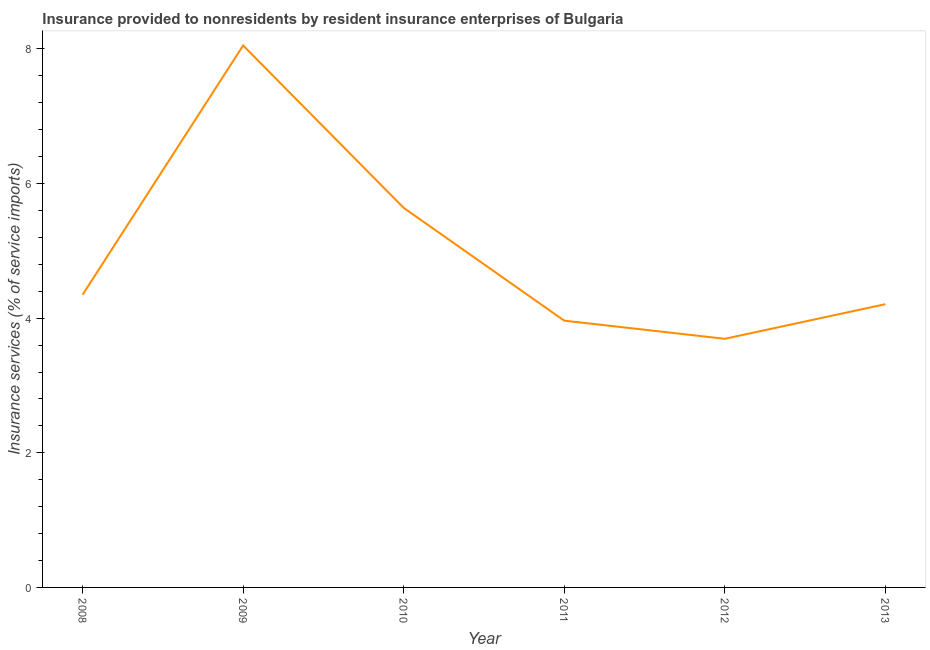What is the insurance and financial services in 2012?
Your answer should be compact. 3.69. Across all years, what is the maximum insurance and financial services?
Your answer should be very brief. 8.05. Across all years, what is the minimum insurance and financial services?
Make the answer very short. 3.69. What is the sum of the insurance and financial services?
Your answer should be very brief. 29.9. What is the difference between the insurance and financial services in 2012 and 2013?
Give a very brief answer. -0.51. What is the average insurance and financial services per year?
Make the answer very short. 4.98. What is the median insurance and financial services?
Make the answer very short. 4.28. What is the ratio of the insurance and financial services in 2008 to that in 2009?
Your response must be concise. 0.54. Is the insurance and financial services in 2010 less than that in 2013?
Make the answer very short. No. What is the difference between the highest and the second highest insurance and financial services?
Ensure brevity in your answer.  2.41. What is the difference between the highest and the lowest insurance and financial services?
Provide a succinct answer. 4.36. How many lines are there?
Make the answer very short. 1. Does the graph contain any zero values?
Offer a terse response. No. Does the graph contain grids?
Make the answer very short. No. What is the title of the graph?
Your answer should be compact. Insurance provided to nonresidents by resident insurance enterprises of Bulgaria. What is the label or title of the X-axis?
Offer a terse response. Year. What is the label or title of the Y-axis?
Your answer should be very brief. Insurance services (% of service imports). What is the Insurance services (% of service imports) of 2008?
Offer a terse response. 4.35. What is the Insurance services (% of service imports) of 2009?
Offer a very short reply. 8.05. What is the Insurance services (% of service imports) in 2010?
Your answer should be compact. 5.64. What is the Insurance services (% of service imports) of 2011?
Make the answer very short. 3.96. What is the Insurance services (% of service imports) of 2012?
Offer a terse response. 3.69. What is the Insurance services (% of service imports) of 2013?
Provide a short and direct response. 4.21. What is the difference between the Insurance services (% of service imports) in 2008 and 2009?
Provide a succinct answer. -3.7. What is the difference between the Insurance services (% of service imports) in 2008 and 2010?
Provide a short and direct response. -1.29. What is the difference between the Insurance services (% of service imports) in 2008 and 2011?
Keep it short and to the point. 0.38. What is the difference between the Insurance services (% of service imports) in 2008 and 2012?
Provide a short and direct response. 0.65. What is the difference between the Insurance services (% of service imports) in 2008 and 2013?
Offer a very short reply. 0.14. What is the difference between the Insurance services (% of service imports) in 2009 and 2010?
Provide a short and direct response. 2.41. What is the difference between the Insurance services (% of service imports) in 2009 and 2011?
Give a very brief answer. 4.09. What is the difference between the Insurance services (% of service imports) in 2009 and 2012?
Offer a terse response. 4.36. What is the difference between the Insurance services (% of service imports) in 2009 and 2013?
Your answer should be very brief. 3.84. What is the difference between the Insurance services (% of service imports) in 2010 and 2011?
Ensure brevity in your answer.  1.68. What is the difference between the Insurance services (% of service imports) in 2010 and 2012?
Provide a short and direct response. 1.95. What is the difference between the Insurance services (% of service imports) in 2010 and 2013?
Give a very brief answer. 1.43. What is the difference between the Insurance services (% of service imports) in 2011 and 2012?
Make the answer very short. 0.27. What is the difference between the Insurance services (% of service imports) in 2011 and 2013?
Give a very brief answer. -0.24. What is the difference between the Insurance services (% of service imports) in 2012 and 2013?
Make the answer very short. -0.51. What is the ratio of the Insurance services (% of service imports) in 2008 to that in 2009?
Keep it short and to the point. 0.54. What is the ratio of the Insurance services (% of service imports) in 2008 to that in 2010?
Offer a very short reply. 0.77. What is the ratio of the Insurance services (% of service imports) in 2008 to that in 2011?
Your answer should be very brief. 1.1. What is the ratio of the Insurance services (% of service imports) in 2008 to that in 2012?
Your response must be concise. 1.18. What is the ratio of the Insurance services (% of service imports) in 2008 to that in 2013?
Provide a short and direct response. 1.03. What is the ratio of the Insurance services (% of service imports) in 2009 to that in 2010?
Provide a short and direct response. 1.43. What is the ratio of the Insurance services (% of service imports) in 2009 to that in 2011?
Give a very brief answer. 2.03. What is the ratio of the Insurance services (% of service imports) in 2009 to that in 2012?
Your response must be concise. 2.18. What is the ratio of the Insurance services (% of service imports) in 2009 to that in 2013?
Your response must be concise. 1.91. What is the ratio of the Insurance services (% of service imports) in 2010 to that in 2011?
Ensure brevity in your answer.  1.42. What is the ratio of the Insurance services (% of service imports) in 2010 to that in 2012?
Offer a terse response. 1.53. What is the ratio of the Insurance services (% of service imports) in 2010 to that in 2013?
Give a very brief answer. 1.34. What is the ratio of the Insurance services (% of service imports) in 2011 to that in 2012?
Offer a terse response. 1.07. What is the ratio of the Insurance services (% of service imports) in 2011 to that in 2013?
Make the answer very short. 0.94. What is the ratio of the Insurance services (% of service imports) in 2012 to that in 2013?
Your answer should be compact. 0.88. 